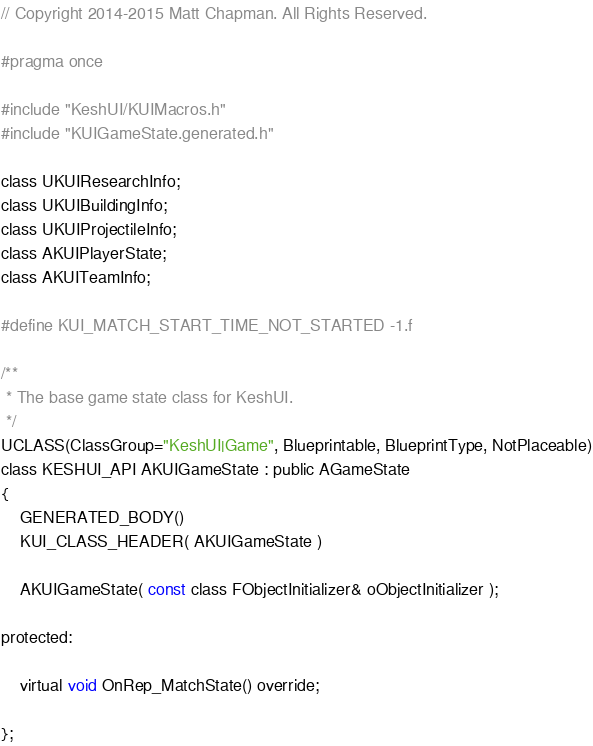Convert code to text. <code><loc_0><loc_0><loc_500><loc_500><_C_>// Copyright 2014-2015 Matt Chapman. All Rights Reserved.

#pragma once

#include "KeshUI/KUIMacros.h"
#include "KUIGameState.generated.h"

class UKUIResearchInfo;
class UKUIBuildingInfo;
class UKUIProjectileInfo;
class AKUIPlayerState;
class AKUITeamInfo;

#define KUI_MATCH_START_TIME_NOT_STARTED -1.f

/**
 * The base game state class for KeshUI.
 */
UCLASS(ClassGroup="KeshUI|Game", Blueprintable, BlueprintType, NotPlaceable)
class KESHUI_API AKUIGameState : public AGameState
{
	GENERATED_BODY()
	KUI_CLASS_HEADER( AKUIGameState )

	AKUIGameState( const class FObjectInitializer& oObjectInitializer );

protected:

	virtual void OnRep_MatchState() override;

};
</code> 